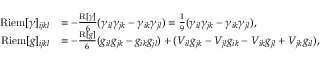Convert formula to latex. <formula><loc_0><loc_0><loc_500><loc_500>\begin{array} { r l } { R i e m [ \gamma ] _ { i j k l } } & { = - \frac { R [ \gamma ] } { 6 } ( \gamma _ { i l } \gamma _ { j k } - \gamma _ { i k } \gamma _ { j l } ) = \frac { 1 } { 9 } ( \gamma _ { i l } \gamma _ { j k } - \gamma _ { i k } \gamma _ { j l } ) , } \\ { R i e m [ g ] _ { i j k l } } & { = - \frac { R [ g ] } { 6 } ( g _ { i l } g _ { j k } - g _ { i k } g _ { j l } ) + ( V _ { i l } g _ { j k } - V _ { j l } g _ { i k } - V _ { i k } g _ { j l } + V _ { j k } g _ { i l } ) , } \end{array}</formula> 